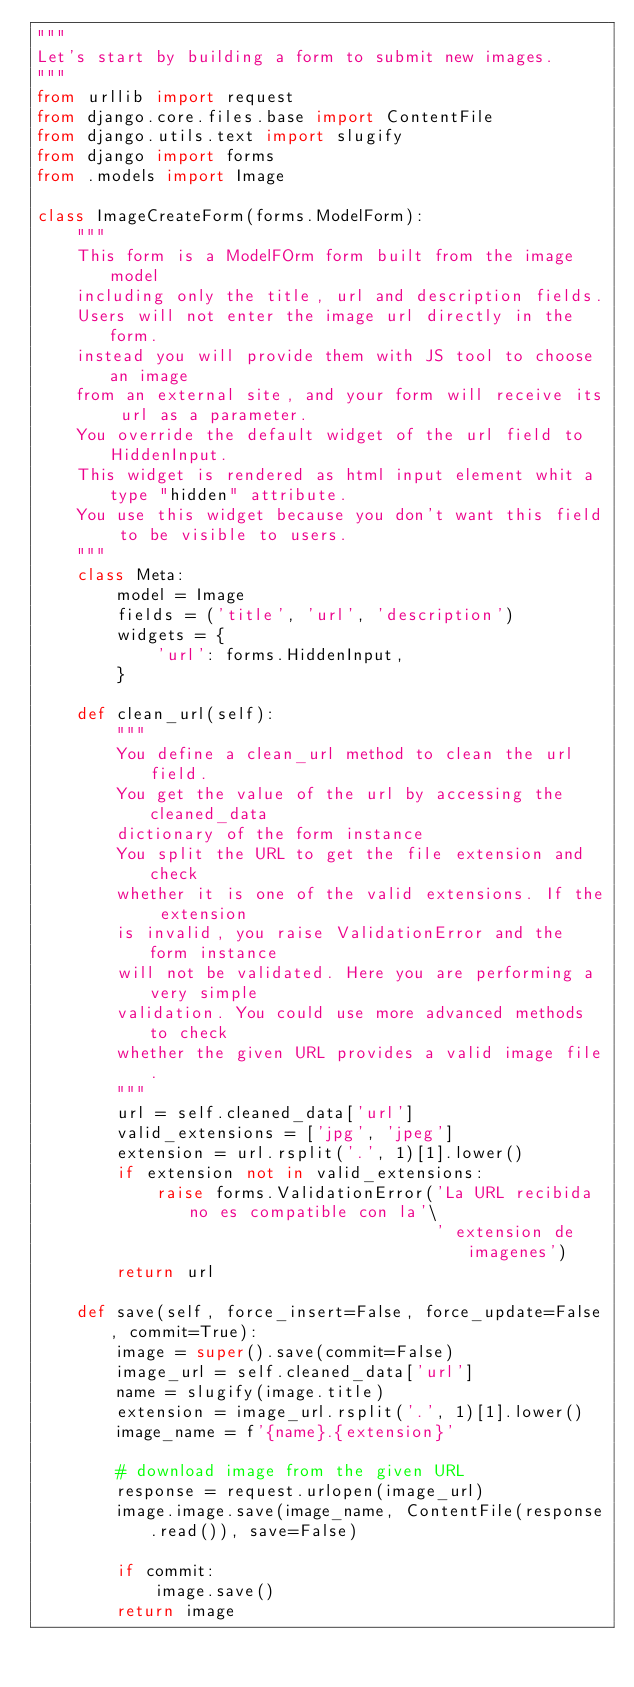<code> <loc_0><loc_0><loc_500><loc_500><_Python_>""" 
Let's start by building a form to submit new images.
"""
from urllib import request
from django.core.files.base import ContentFile
from django.utils.text import slugify
from django import forms
from .models import Image

class ImageCreateForm(forms.ModelForm):
    """ 
    This form is a ModelFOrm form built from the image model
    including only the title, url and description fields.
    Users will not enter the image url directly in the form.
    instead you will provide them with JS tool to choose an image
    from an external site, and your form will receive its url as a parameter.
    You override the default widget of the url field to HiddenInput.
    This widget is rendered as html input element whit a type "hidden" attribute.
    You use this widget because you don't want this field to be visible to users.
    """
    class Meta:
        model = Image
        fields = ('title', 'url', 'description')
        widgets = {
            'url': forms.HiddenInput,
        }

    def clean_url(self):
        """
        You define a clean_url method to clean the url field.
        You get the value of the url by accessing the cleaned_data
        dictionary of the form instance
        You split the URL to get the file extension and check
        whether it is one of the valid extensions. If the extension
        is invalid, you raise ValidationError and the form instance
        will not be validated. Here you are performing a very simple
        validation. You could use more advanced methods to check
        whether the given URL provides a valid image file.
        """
        url = self.cleaned_data['url']
        valid_extensions = ['jpg', 'jpeg']
        extension = url.rsplit('.', 1)[1].lower()
        if extension not in valid_extensions:
            raise forms.ValidationError('La URL recibida no es compatible con la'\
                                        ' extension de imagenes')
        return url

    def save(self, force_insert=False, force_update=False, commit=True):
        image = super().save(commit=False)
        image_url = self.cleaned_data['url']
        name = slugify(image.title)
        extension = image_url.rsplit('.', 1)[1].lower()
        image_name = f'{name}.{extension}'

        # download image from the given URL
        response = request.urlopen(image_url)
        image.image.save(image_name, ContentFile(response.read()), save=False)

        if commit:
            image.save()
        return image
</code> 